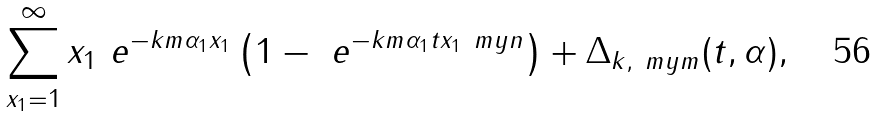<formula> <loc_0><loc_0><loc_500><loc_500>\sum _ { x _ { 1 } = 1 } ^ { \infty } x _ { 1 } \ e ^ { - k m \alpha _ { 1 } x _ { 1 } } \left ( 1 - \ e ^ { - k m \alpha _ { 1 } t x _ { 1 } \ m y n } \right ) + \Delta _ { k , \ m y m } ( t , \alpha ) ,</formula> 